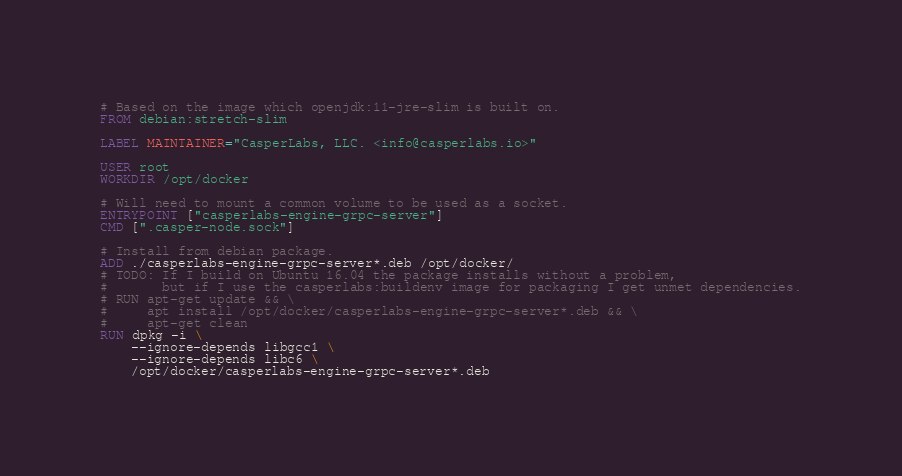<code> <loc_0><loc_0><loc_500><loc_500><_Dockerfile_># Based on the image which openjdk:11-jre-slim is built on.
FROM debian:stretch-slim

LABEL MAINTAINER="CasperLabs, LLC. <info@casperlabs.io>"

USER root
WORKDIR /opt/docker

# Will need to mount a common volume to be used as a socket.
ENTRYPOINT ["casperlabs-engine-grpc-server"]
CMD [".casper-node.sock"]

# Install from debian package.
ADD ./casperlabs-engine-grpc-server*.deb /opt/docker/
# TODO: If I build on Ubuntu 16.04 the package installs without a problem,
# 		but if I use the casperlabs:buildenv image for packaging I get unmet dependencies.
# RUN apt-get update && \
#     apt install /opt/docker/casperlabs-engine-grpc-server*.deb && \
#     apt-get clean
RUN dpkg -i \
    --ignore-depends libgcc1 \
    --ignore-depends libc6 \
    /opt/docker/casperlabs-engine-grpc-server*.deb</code> 